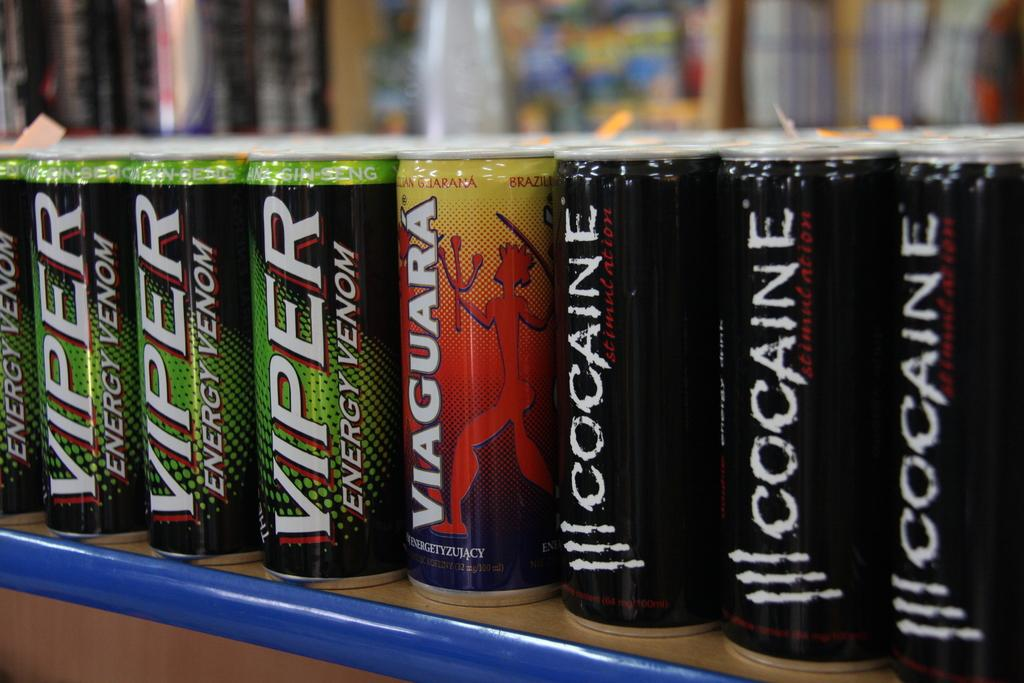<image>
Offer a succinct explanation of the picture presented. Three cans of Cocaine energy drink are lined up on a shelf. 